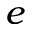<formula> <loc_0><loc_0><loc_500><loc_500>e</formula> 